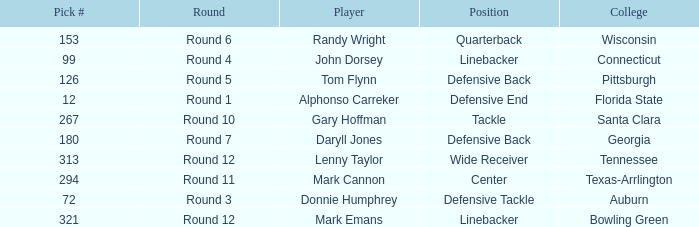In what Round was Pick #12 drafted? Round 1. 